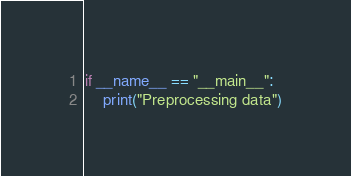<code> <loc_0><loc_0><loc_500><loc_500><_Python_>if __name__ == "__main__":
    print("Preprocessing data")


</code> 